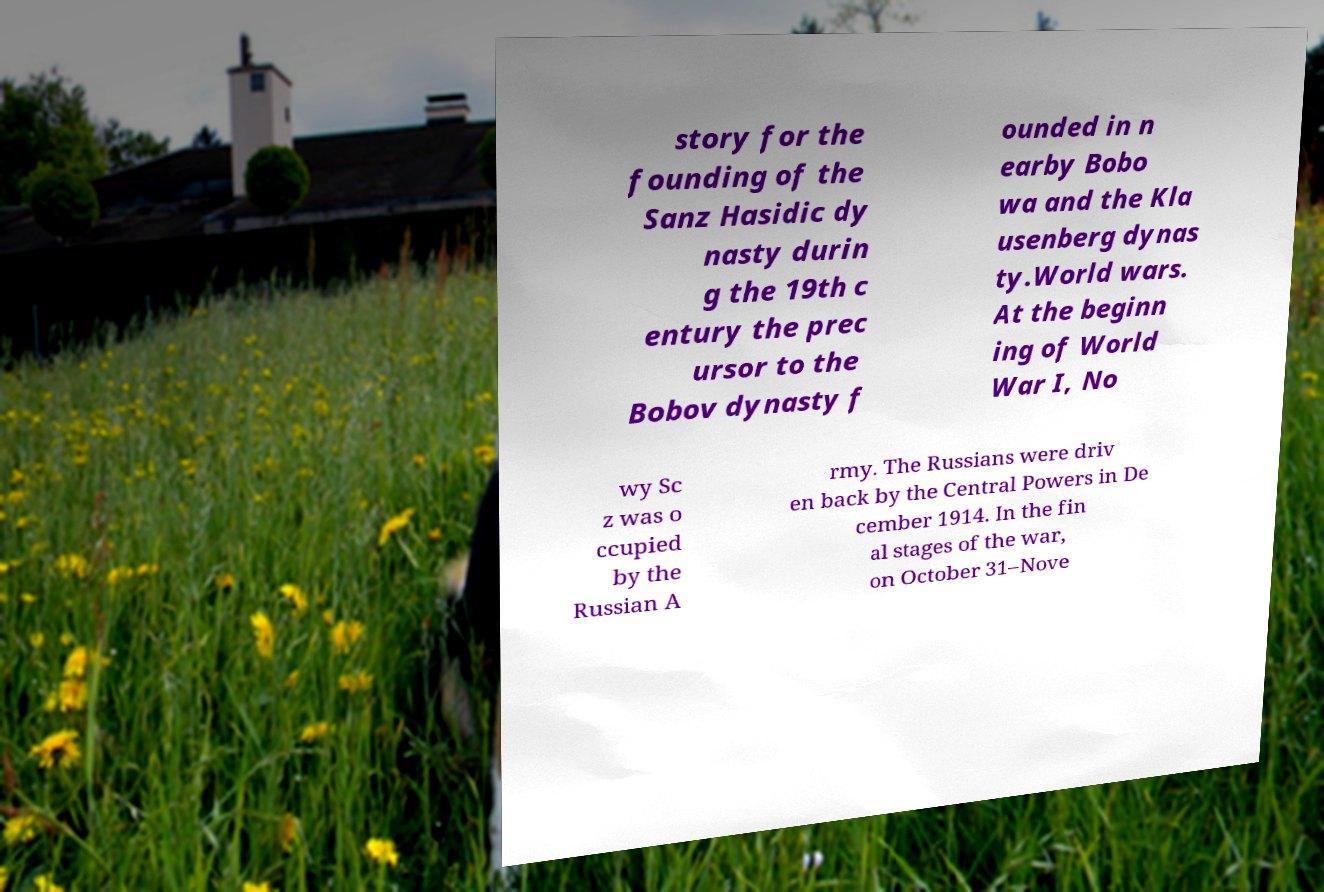There's text embedded in this image that I need extracted. Can you transcribe it verbatim? story for the founding of the Sanz Hasidic dy nasty durin g the 19th c entury the prec ursor to the Bobov dynasty f ounded in n earby Bobo wa and the Kla usenberg dynas ty.World wars. At the beginn ing of World War I, No wy Sc z was o ccupied by the Russian A rmy. The Russians were driv en back by the Central Powers in De cember 1914. In the fin al stages of the war, on October 31–Nove 